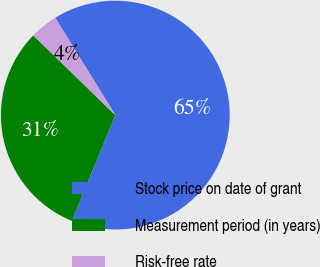Convert chart to OTSL. <chart><loc_0><loc_0><loc_500><loc_500><pie_chart><fcel>Stock price on date of grant<fcel>Measurement period (in years)<fcel>Risk-free rate<nl><fcel>65.01%<fcel>31.06%<fcel>3.93%<nl></chart> 